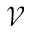Convert formula to latex. <formula><loc_0><loc_0><loc_500><loc_500>\mathcal { V }</formula> 